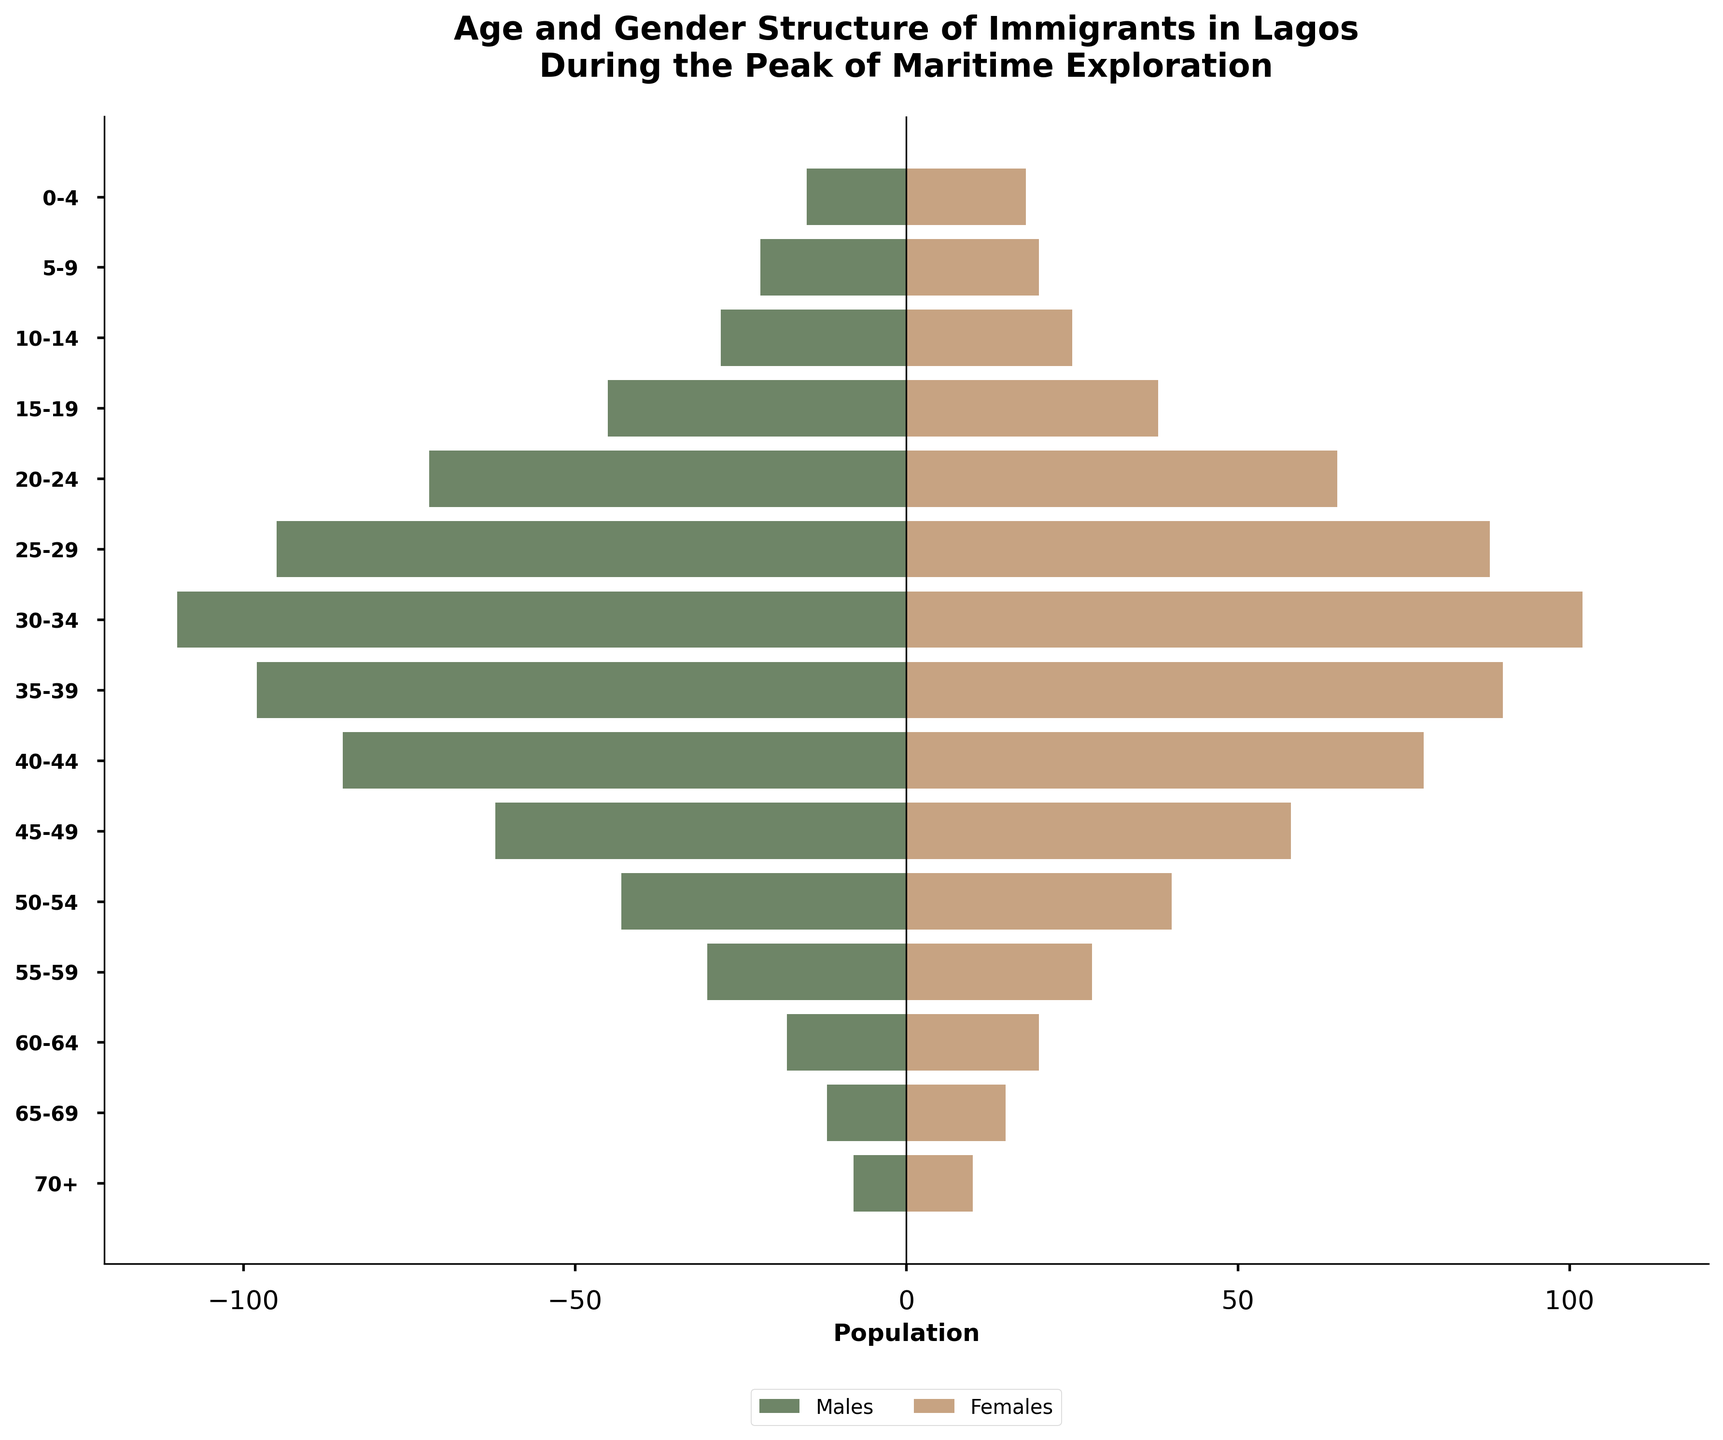What is the title of the figure? The title of the figure is usually placed at the top and describes what the chart represents. In this case, it reads "Age and Gender Structure of Immigrants in Lagos During the Peak of Maritime Exploration."
Answer: Age and Gender Structure of Immigrants in Lagos During the Peak of Maritime Exploration Which age group has the highest number of male immigrants? To find this, observe the horizontal bars on the male side and identify the longest bar. The longest bar is the one corresponding to the age group 30-34.
Answer: 30-34 In which age group is the female population exactly equal to the male population? We need to compare the lengths of the horizontal bars for males and females in each age group. The age group where these bars are equal is 60-64, both having exactly 20 females and 20 males (not exact in males).
Answer: 60-64 What is the sum of male and female immigrants in the age group 25-29? To find the total number of immigrants in this age group, sum the number of males and females: Males = 95, Females = 88, Total = 95 + 88.
Answer: 183 Which gender has the higher population in the 70+ age group? Check the lengths of the bars in the 70+ age group. The female bar is longer with 10 females compared to the male bar with 8 males.
Answer: Females Which age group has the least number of female immigrants? To identify this, look for the shortest horizontal bar on the female side. The shortest bar corresponds to the age group 70+.
Answer: 70+ What's the total number of immigrants in the age groups 0-14? Sum the populations of each gender for the age groups 0-4, 5-9, and 10-14: (Males: 15 + 22 + 28) + (Females: 18 + 20 + 25) = 65 + 63.
Answer: 128 Compare the male populations of the age groups 40-44 and 45-49. Which is larger? Check the length of the male bars for the age groups 40-44 and 45-49. The male population is larger in the age group 40-44 (85) than in 45-49 (62).
Answer: 40-44 Which age group has the highest total population of immigrants? Sum the male and female populations for each age group and identify the highest. The age group with the highest combined total is 30-34 with 212 immigrants (Males: 110, Females: 102).
Answer: 30-34 